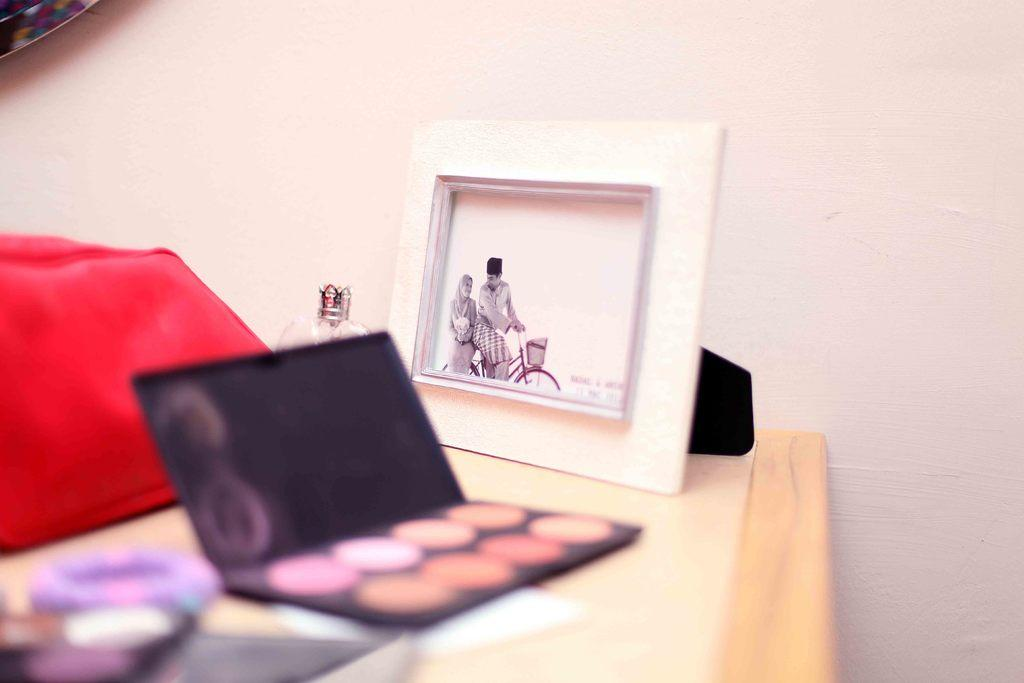What object in the image contains a picture of two persons? The photo frame in the image contains an image of two persons riding a bicycle. Where is the photo frame located in the image? The photo frame is placed on a table. What other items can be seen on the table in the image? There is makeup stuff on the table. What type of brass instrument is being played by the person on the left in the image? There is no brass instrument or person playing it in the image; it only contains a photo frame with an image of two persons riding a bicycle. 